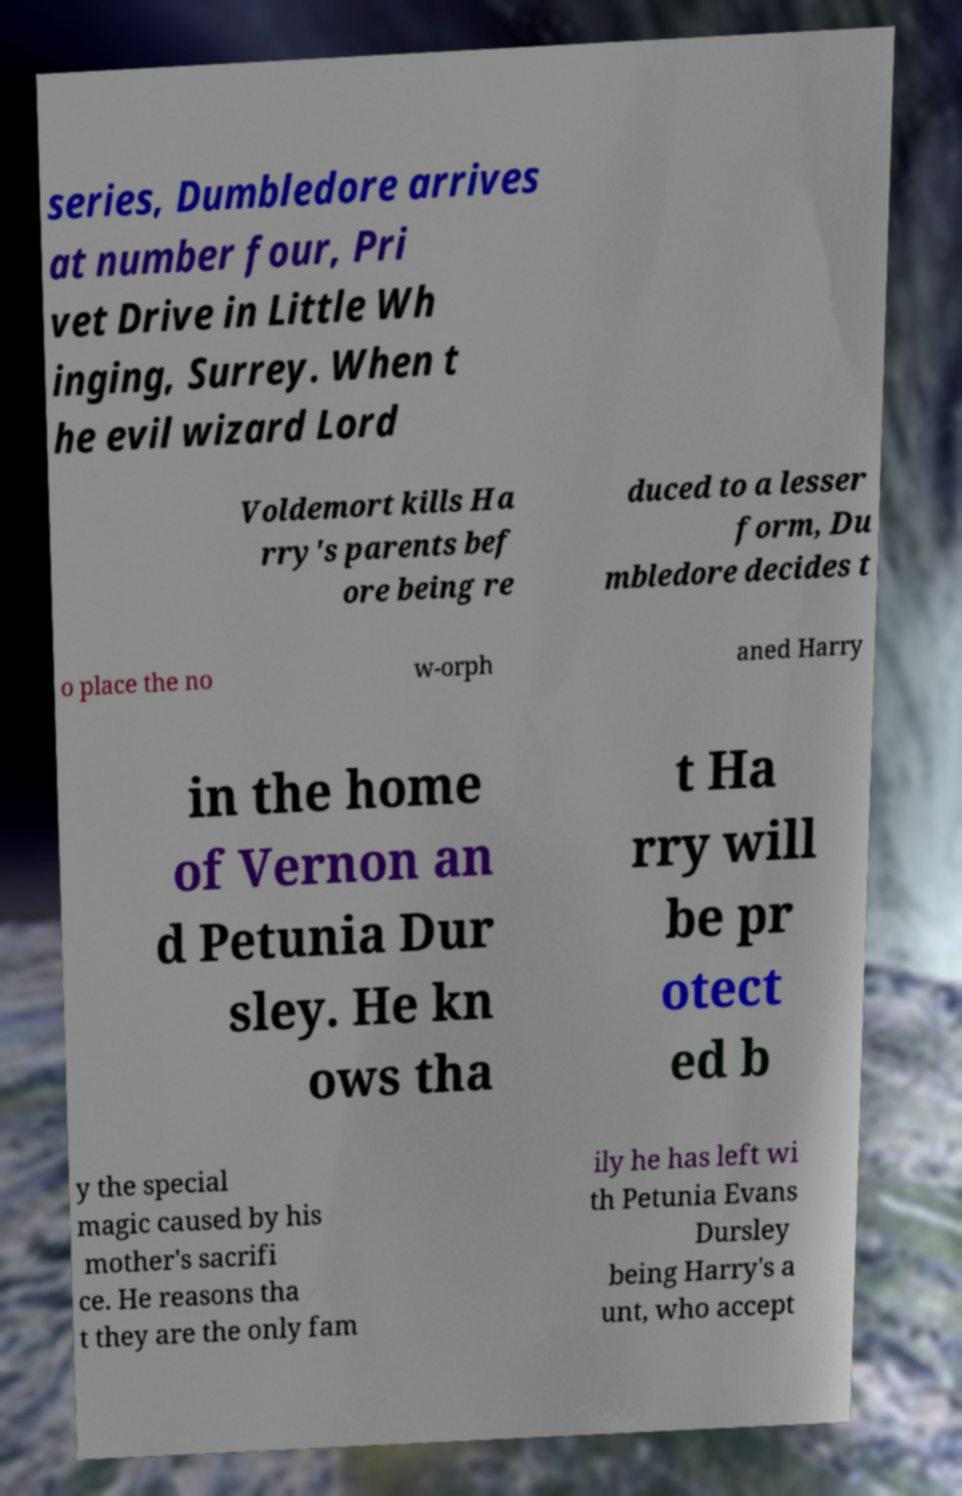Could you assist in decoding the text presented in this image and type it out clearly? series, Dumbledore arrives at number four, Pri vet Drive in Little Wh inging, Surrey. When t he evil wizard Lord Voldemort kills Ha rry's parents bef ore being re duced to a lesser form, Du mbledore decides t o place the no w-orph aned Harry in the home of Vernon an d Petunia Dur sley. He kn ows tha t Ha rry will be pr otect ed b y the special magic caused by his mother's sacrifi ce. He reasons tha t they are the only fam ily he has left wi th Petunia Evans Dursley being Harry's a unt, who accept 